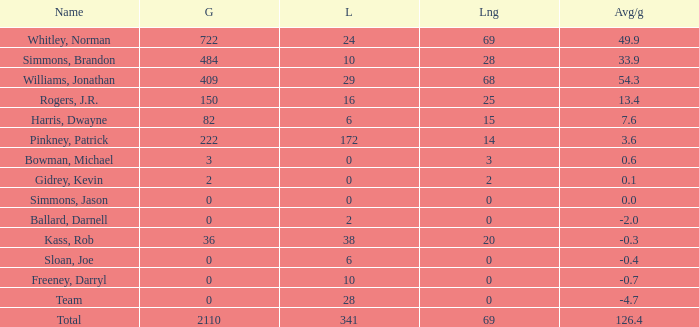What is the highest Loss, when Long is greater than 0, when Gain is greater than 484, and when Avg/g is greater than 126.4? None. 